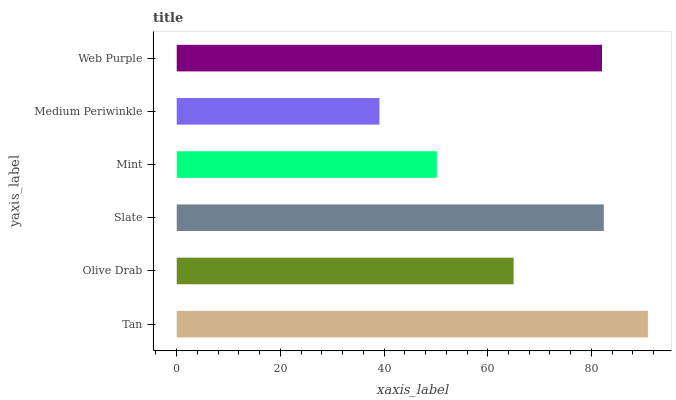Is Medium Periwinkle the minimum?
Answer yes or no. Yes. Is Tan the maximum?
Answer yes or no. Yes. Is Olive Drab the minimum?
Answer yes or no. No. Is Olive Drab the maximum?
Answer yes or no. No. Is Tan greater than Olive Drab?
Answer yes or no. Yes. Is Olive Drab less than Tan?
Answer yes or no. Yes. Is Olive Drab greater than Tan?
Answer yes or no. No. Is Tan less than Olive Drab?
Answer yes or no. No. Is Web Purple the high median?
Answer yes or no. Yes. Is Olive Drab the low median?
Answer yes or no. Yes. Is Medium Periwinkle the high median?
Answer yes or no. No. Is Web Purple the low median?
Answer yes or no. No. 